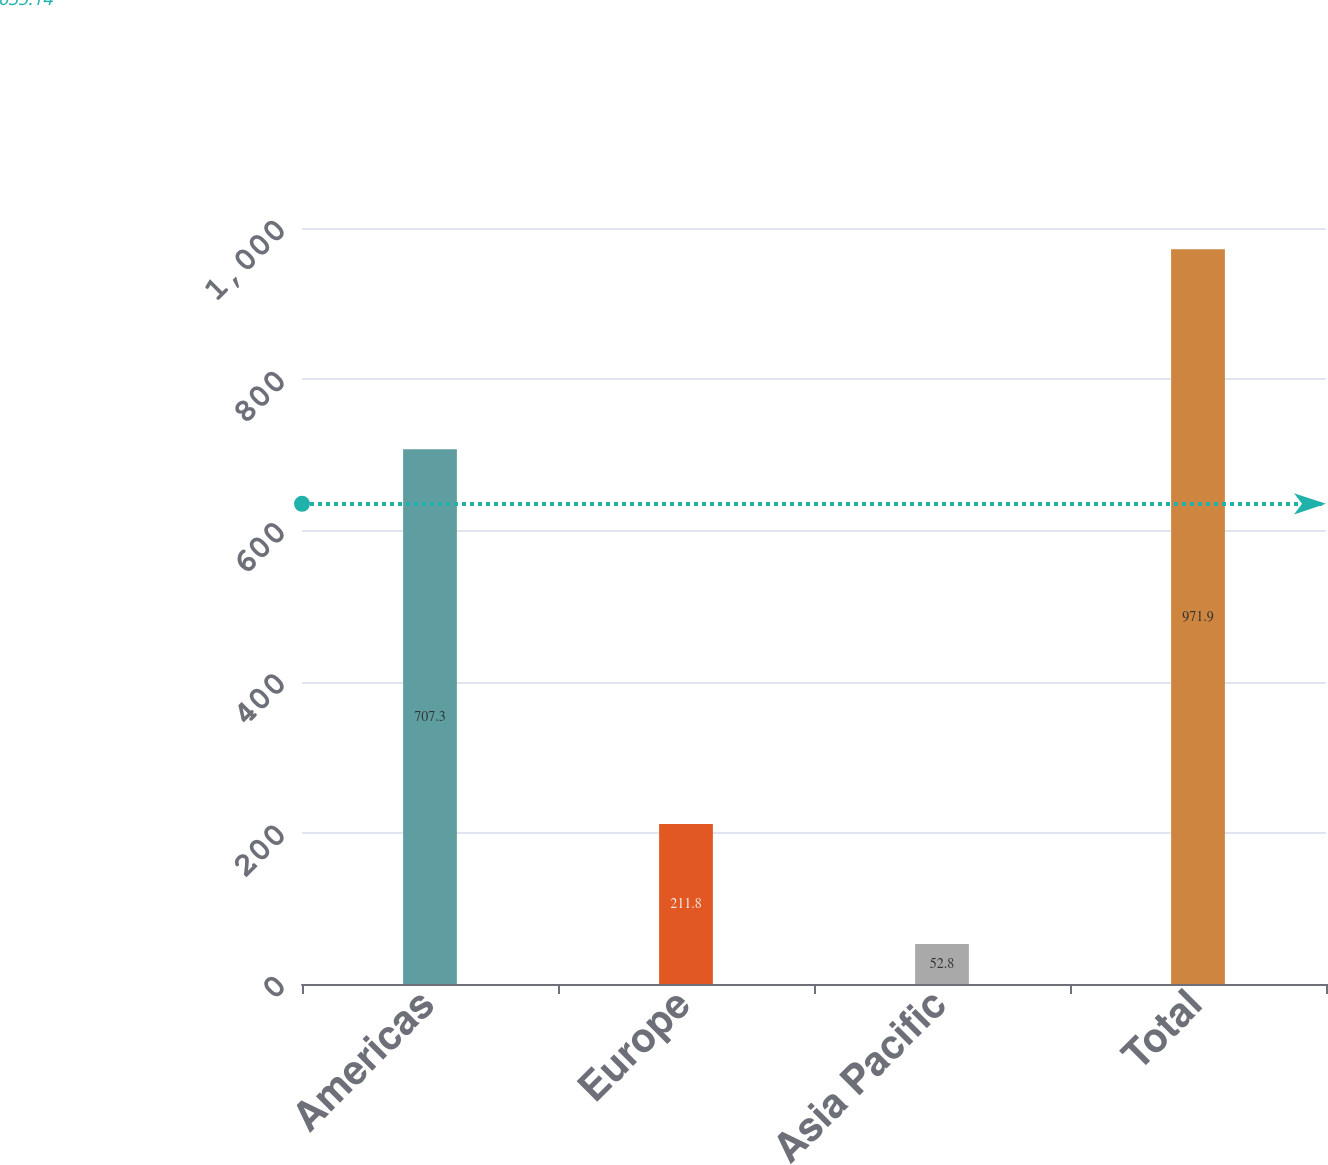<chart> <loc_0><loc_0><loc_500><loc_500><bar_chart><fcel>Americas<fcel>Europe<fcel>Asia Pacific<fcel>Total<nl><fcel>707.3<fcel>211.8<fcel>52.8<fcel>971.9<nl></chart> 